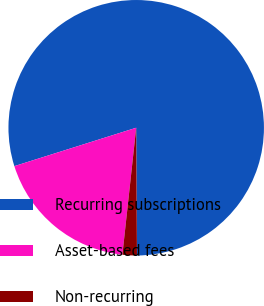Convert chart to OTSL. <chart><loc_0><loc_0><loc_500><loc_500><pie_chart><fcel>Recurring subscriptions<fcel>Asset-based fees<fcel>Non-recurring<nl><fcel>79.77%<fcel>18.42%<fcel>1.82%<nl></chart> 